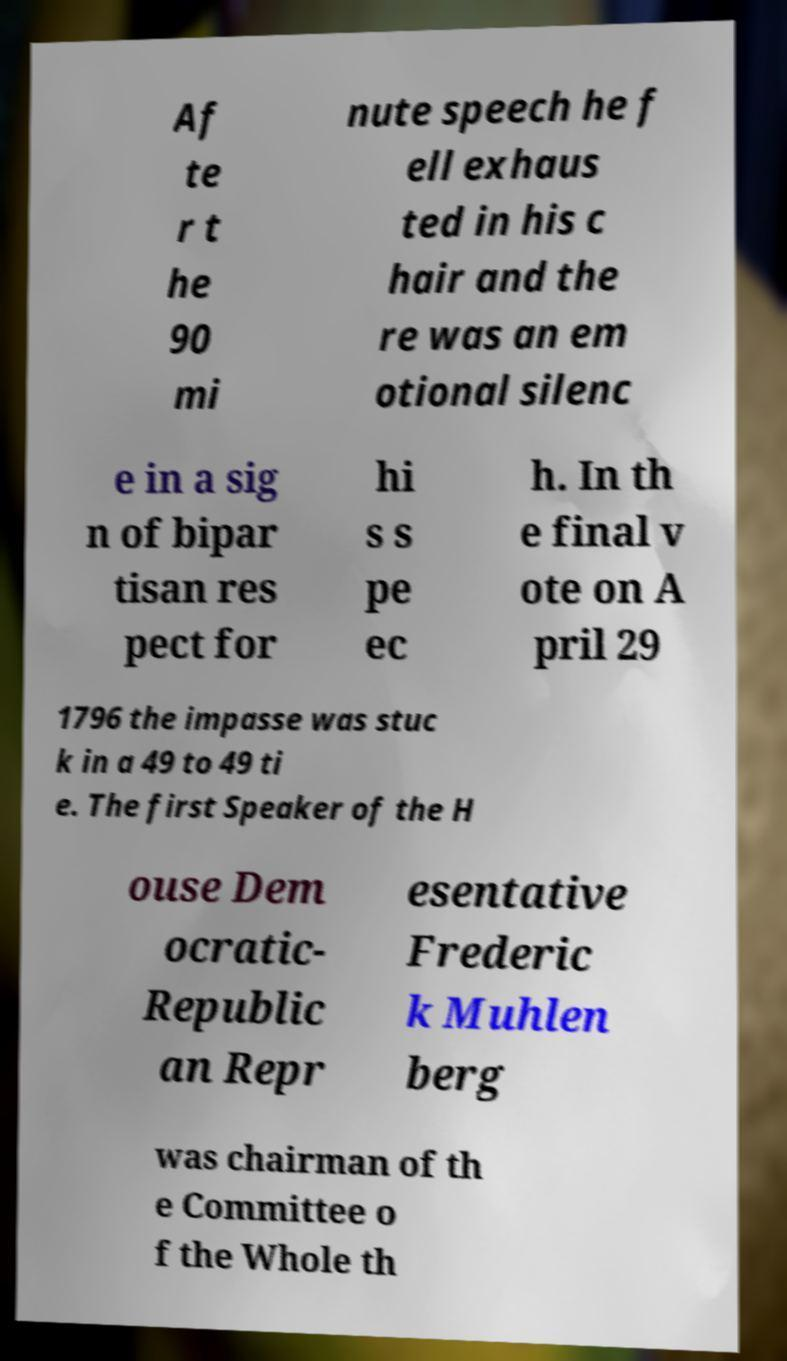For documentation purposes, I need the text within this image transcribed. Could you provide that? Af te r t he 90 mi nute speech he f ell exhaus ted in his c hair and the re was an em otional silenc e in a sig n of bipar tisan res pect for hi s s pe ec h. In th e final v ote on A pril 29 1796 the impasse was stuc k in a 49 to 49 ti e. The first Speaker of the H ouse Dem ocratic- Republic an Repr esentative Frederic k Muhlen berg was chairman of th e Committee o f the Whole th 